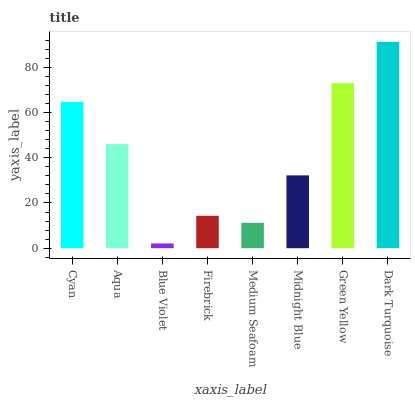Is Aqua the minimum?
Answer yes or no. No. Is Aqua the maximum?
Answer yes or no. No. Is Cyan greater than Aqua?
Answer yes or no. Yes. Is Aqua less than Cyan?
Answer yes or no. Yes. Is Aqua greater than Cyan?
Answer yes or no. No. Is Cyan less than Aqua?
Answer yes or no. No. Is Aqua the high median?
Answer yes or no. Yes. Is Midnight Blue the low median?
Answer yes or no. Yes. Is Midnight Blue the high median?
Answer yes or no. No. Is Blue Violet the low median?
Answer yes or no. No. 